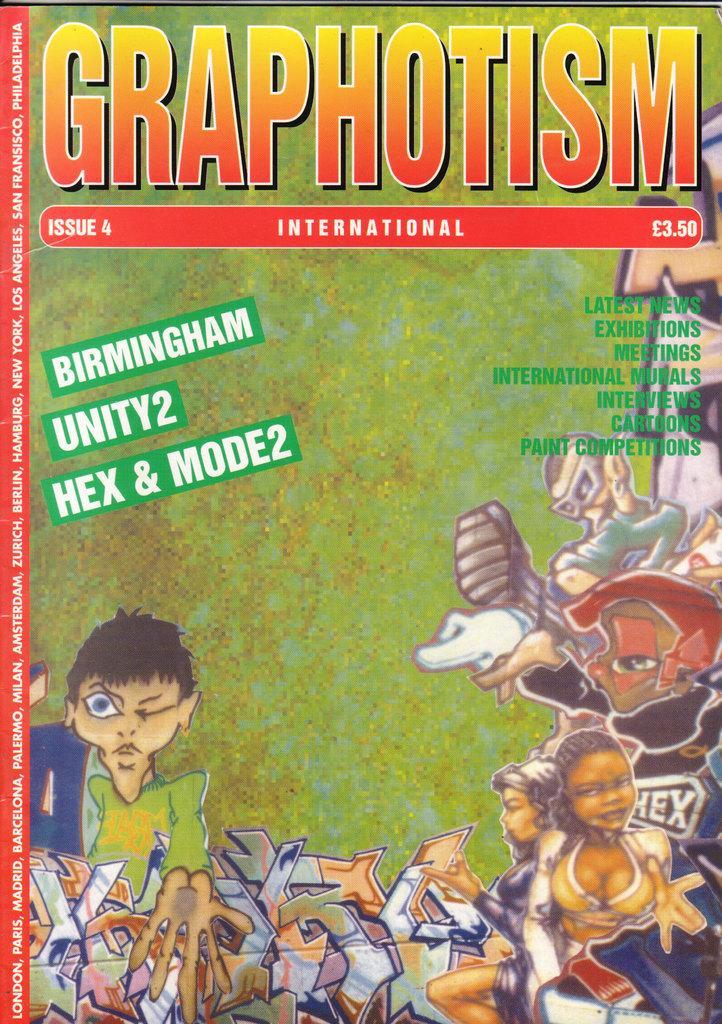In one or two sentences, can you explain what this image depicts? This is a poster and in this poster we can see cartoon images of some persons and some text. 